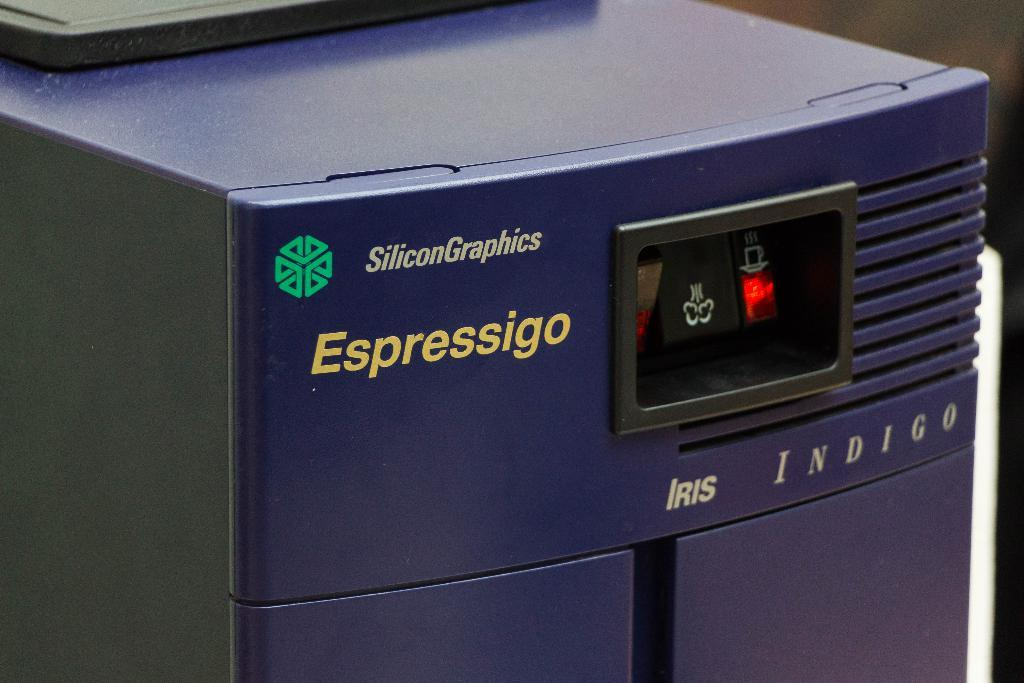What type of appliance can be seen in the image? There is a coffee machine in the image. What might the coffee machine be used for? The coffee machine is likely used for brewing coffee. Can you describe the appearance of the coffee machine? The coffee machine appears to be a standard countertop model with buttons or dials for operation. What type of stick can be seen in the image? There is no stick present in the image; it only features a coffee machine. 